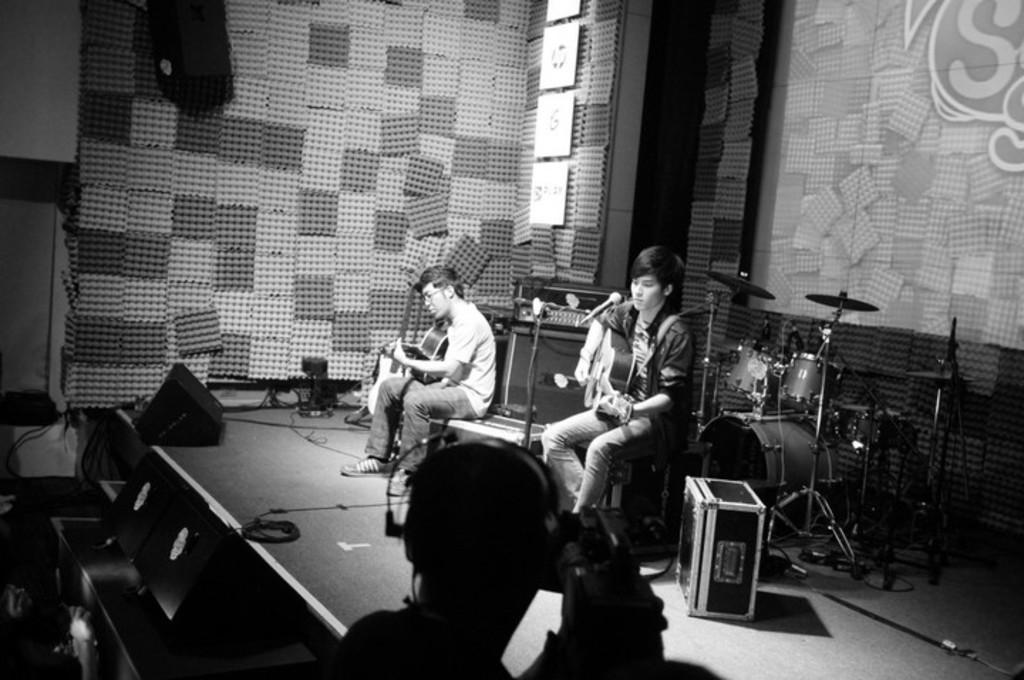How would you summarize this image in a sentence or two? This is a black and white image. In this image we can see two men on the stage holding the guitars. We can also see a mic with a stand, a box, a device on a table, some musical instruments, some wires, the speaker boxes and some boards on a wall. In the foreground we can see a person holding a camera. 